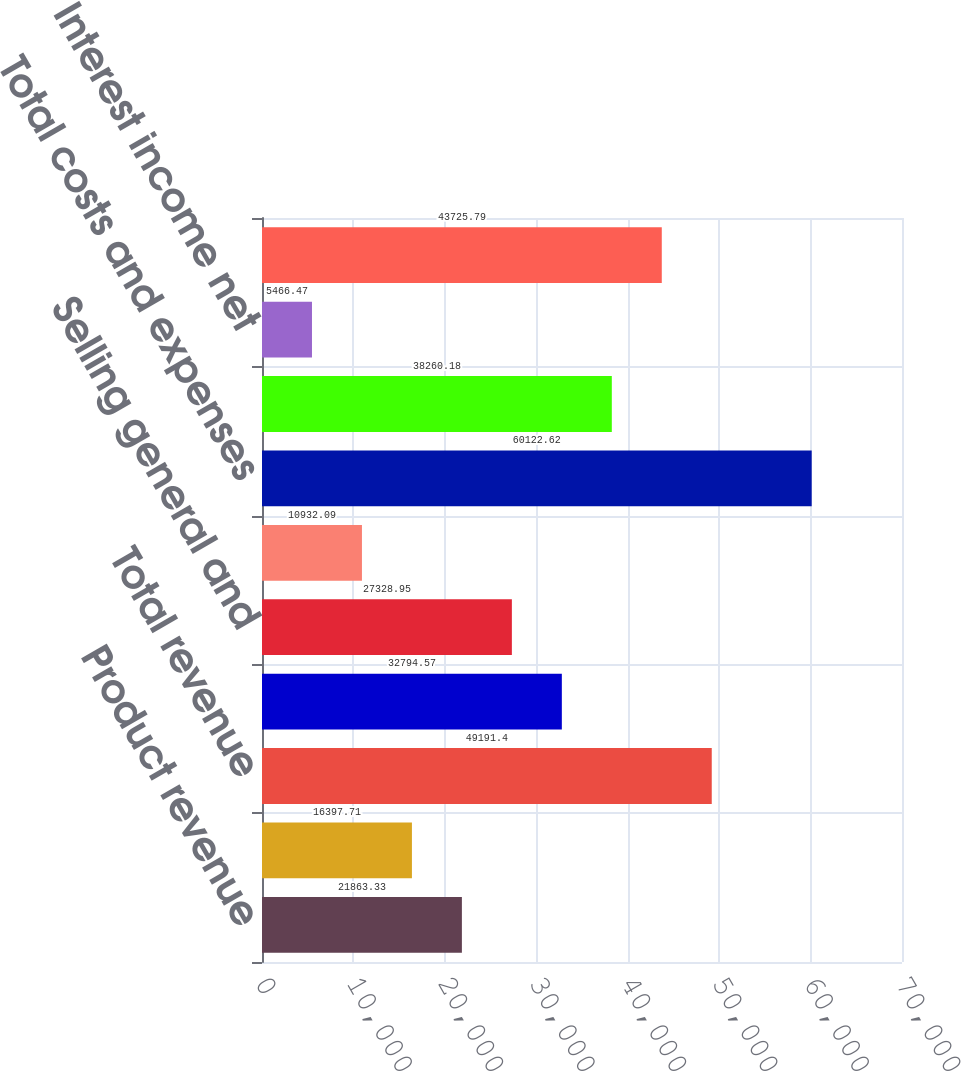<chart> <loc_0><loc_0><loc_500><loc_500><bar_chart><fcel>Product revenue<fcel>Research revenue<fcel>Total revenue<fcel>Research and development<fcel>Selling general and<fcel>Amortization of deferred<fcel>Total costs and expenses<fcel>Loss from operations<fcel>Interest income net<fcel>Net loss<nl><fcel>21863.3<fcel>16397.7<fcel>49191.4<fcel>32794.6<fcel>27329<fcel>10932.1<fcel>60122.6<fcel>38260.2<fcel>5466.47<fcel>43725.8<nl></chart> 